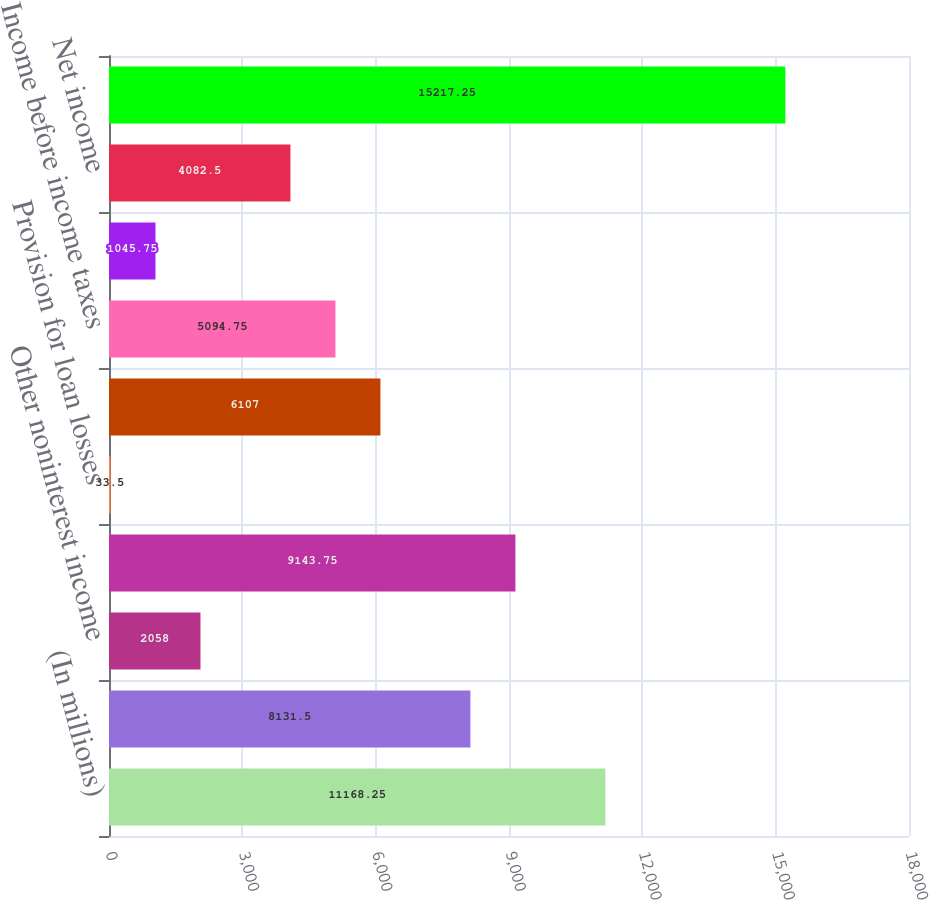Convert chart to OTSL. <chart><loc_0><loc_0><loc_500><loc_500><bar_chart><fcel>(In millions)<fcel>Net interest income<fcel>Other noninterest income<fcel>Total revenue<fcel>Provision for loan losses<fcel>Noninterest expense<fcel>Income before income taxes<fcel>Income tax expense<fcel>Net income<fcel>Total assets<nl><fcel>11168.2<fcel>8131.5<fcel>2058<fcel>9143.75<fcel>33.5<fcel>6107<fcel>5094.75<fcel>1045.75<fcel>4082.5<fcel>15217.2<nl></chart> 